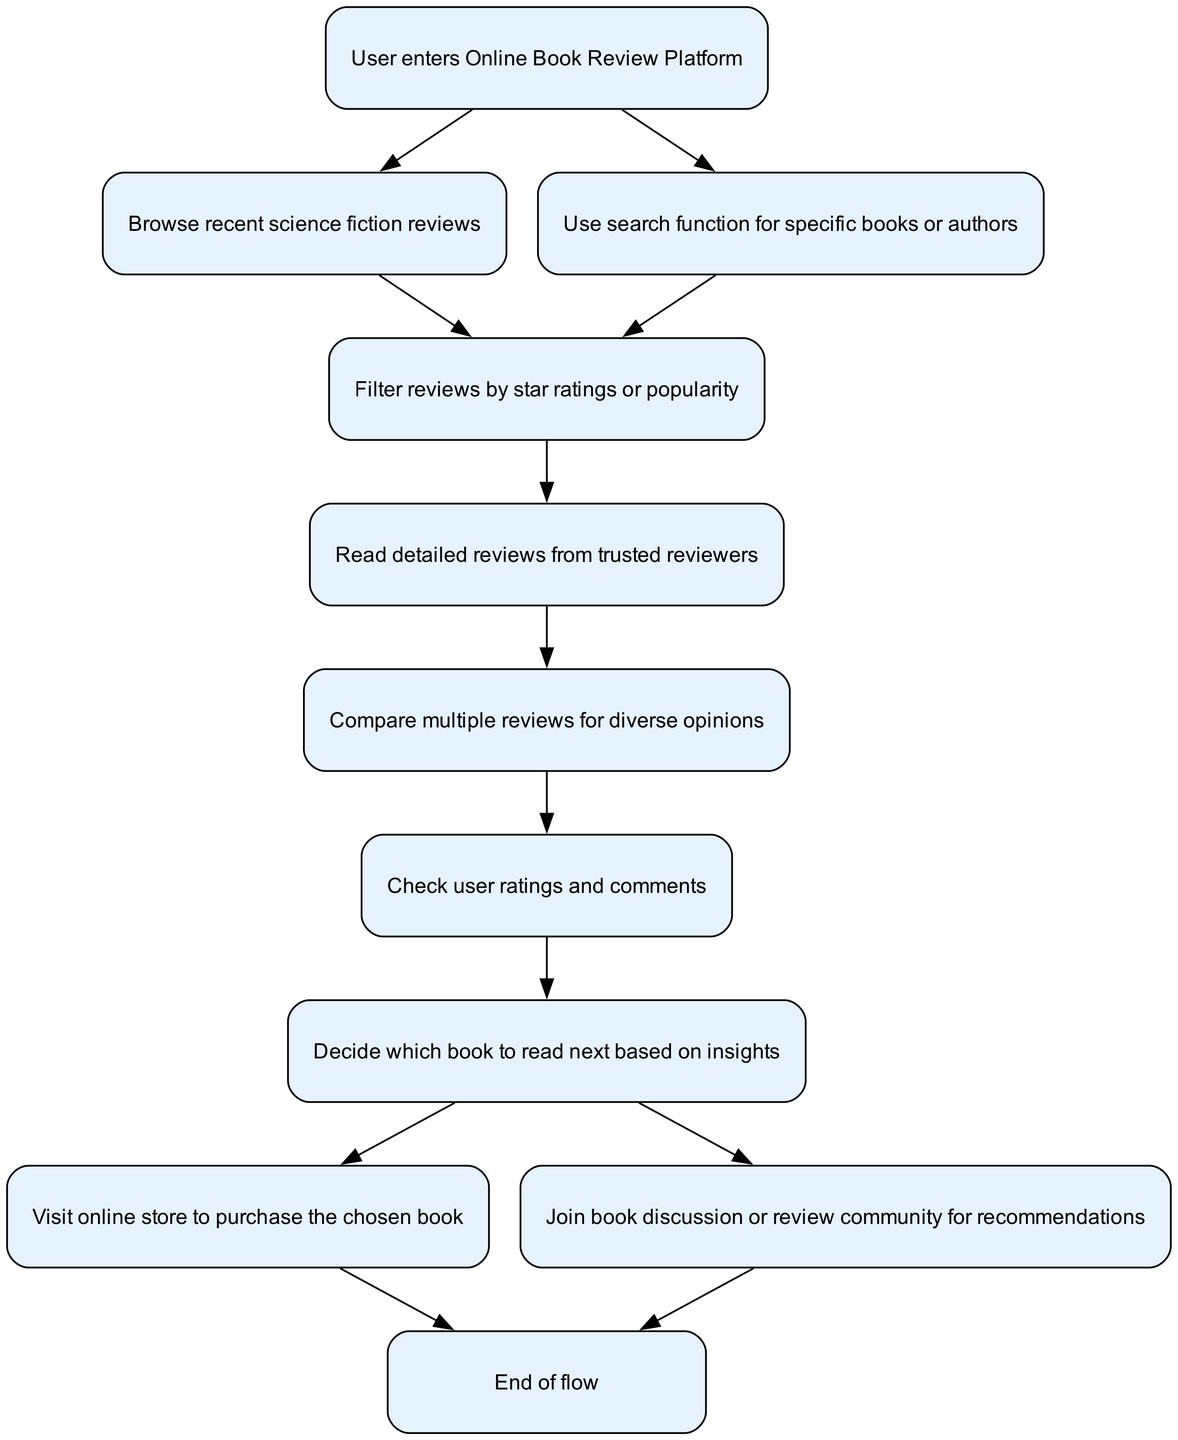What is the first step in the flow? The first step in the flow is represented by the node labeled "User enters Online Book Review Platform." It's the starting point before engaging with any reviews.
Answer: User enters Online Book Review Platform How many main actions can a user take after the first step? From the first step, the user can either "Browse recent science fiction reviews" or "Use search function for specific books or authors." This means there are two main actions available after the start.
Answer: 2 What is the last action before the flow ends? The last action that leads to the flow ending is represented after "Visit online store to purchase the chosen book" and "Join book discussion or review community for recommendations," both of which lead to the "End of flow."
Answer: Make decision Which node involves comparing multiple reviews? The node that involves comparing multiple reviews is labeled "Compare multiple reviews for diverse opinions." This indicates the process of looking at different perspectives before making a choice.
Answer: Compare multiple reviews for diverse opinions What happens after reading detailed reviews? After reading detailed reviews, the user continues to "Compare multiple reviews for diverse opinions," indicating that the next step is to look at various viewpoints before deciding on a book.
Answer: Compare multiple reviews for diverse opinions How many different ways can a user decide what to do after making a decision? After making a decision on which book to read, the user has two options: to "Visit online store to purchase the chosen book" or to "Join book discussion or review community for recommendations," resulting in two distinct paths.
Answer: 2 What action is taken to gather opinions before making a decision? To gather opinions before making a decision, the user will "Check user ratings and comments." This step is crucial for understanding community feedback on specific books.
Answer: Check user ratings and comments What is the purpose of filtering reviews? The purpose of filtering reviews is to "Filter reviews by star ratings or popularity," which helps the user narrow down their selection based on quality or user popularity.
Answer: Filter reviews by star ratings or popularity What is the relationship between "Read detailed reviews" and "Check user ratings"? The relationship is sequential; after "Read detailed reviews," the user proceeds to "Check user ratings and comments," ensuring they are informed both by expert reviews and community feedback.
Answer: Sequential relationship 